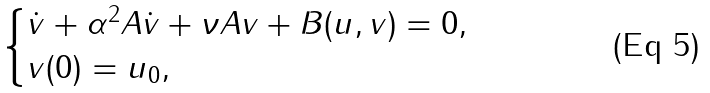<formula> <loc_0><loc_0><loc_500><loc_500>\begin{cases} \dot { v } + \alpha ^ { 2 } A \dot { v } + \nu A v + B ( u , v ) = 0 , \\ v ( 0 ) = u _ { 0 } , \end{cases}</formula> 